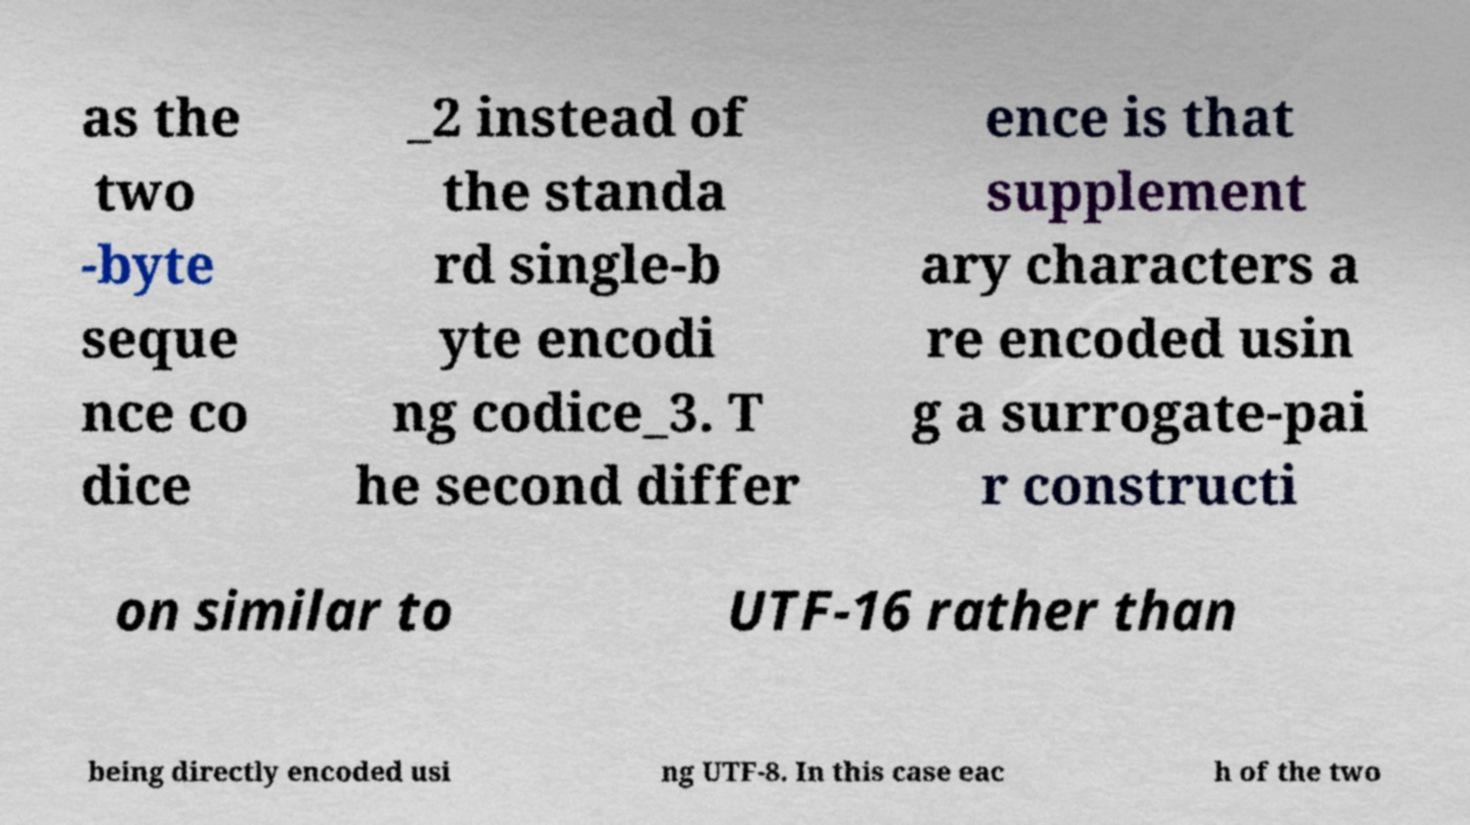For documentation purposes, I need the text within this image transcribed. Could you provide that? as the two -byte seque nce co dice _2 instead of the standa rd single-b yte encodi ng codice_3. T he second differ ence is that supplement ary characters a re encoded usin g a surrogate-pai r constructi on similar to UTF-16 rather than being directly encoded usi ng UTF-8. In this case eac h of the two 